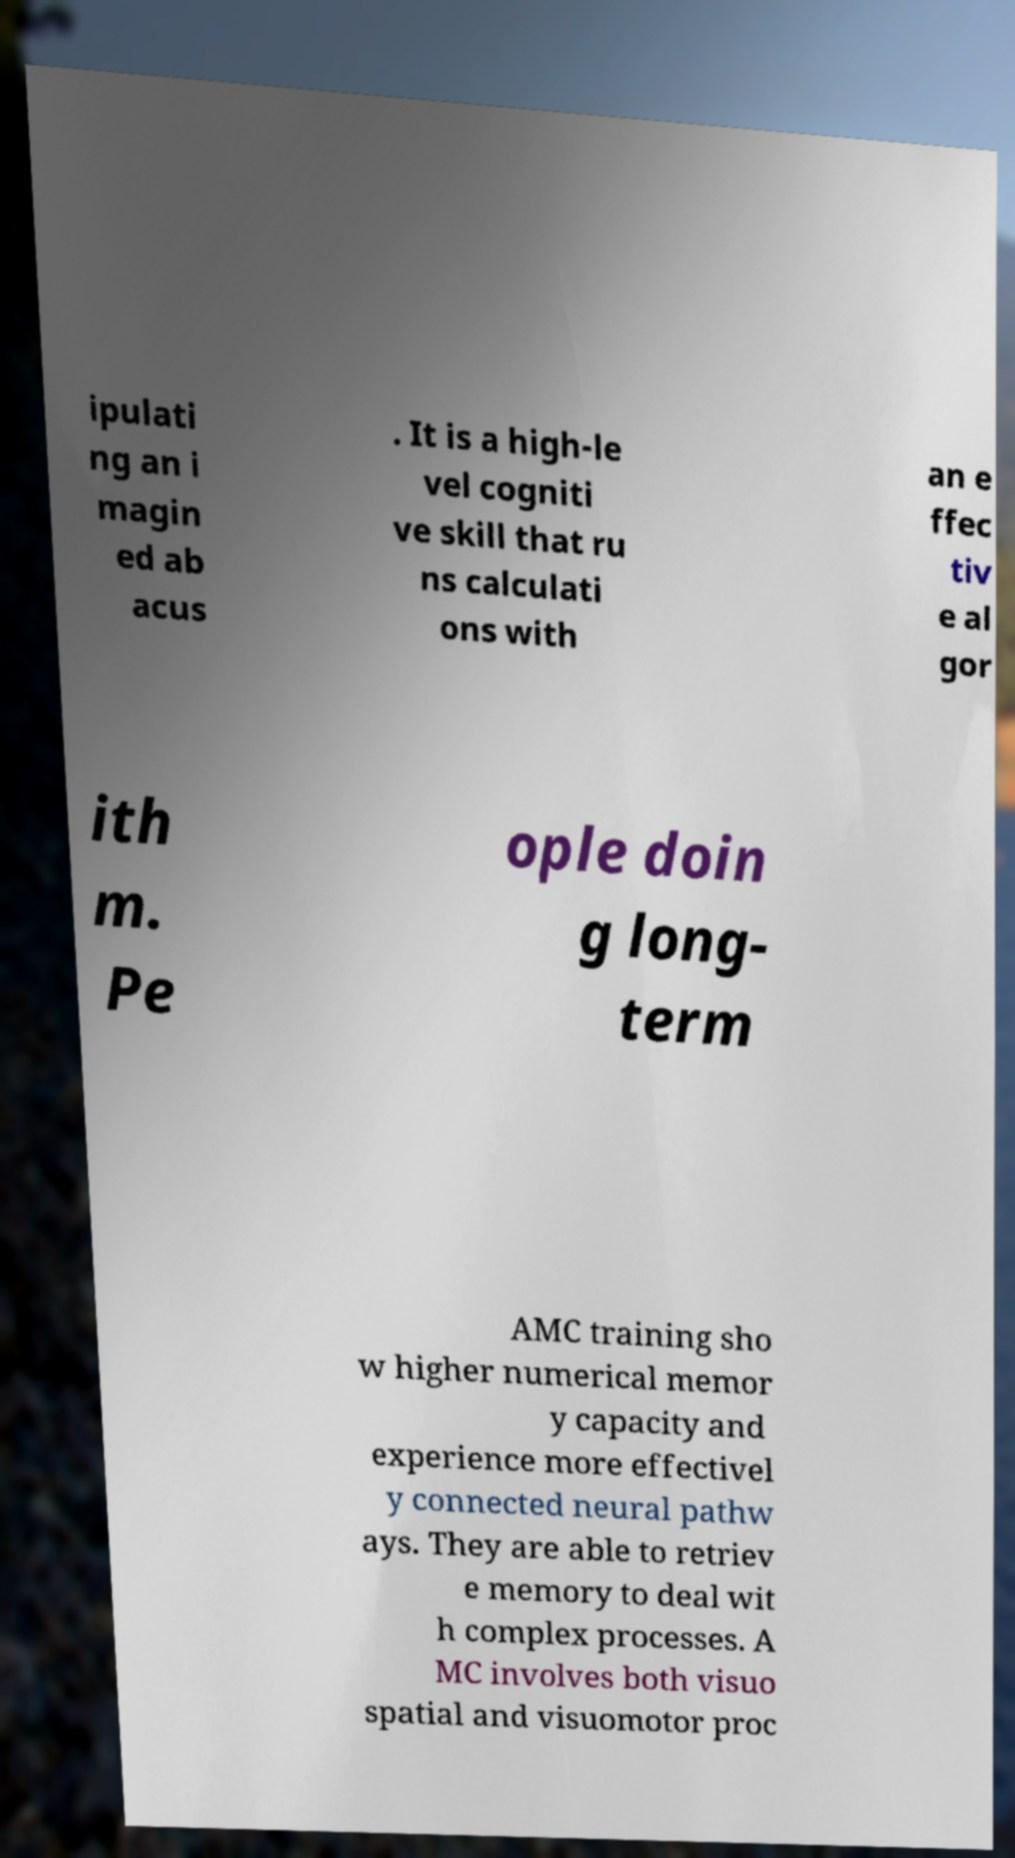Can you accurately transcribe the text from the provided image for me? ipulati ng an i magin ed ab acus . It is a high-le vel cogniti ve skill that ru ns calculati ons with an e ffec tiv e al gor ith m. Pe ople doin g long- term AMC training sho w higher numerical memor y capacity and experience more effectivel y connected neural pathw ays. They are able to retriev e memory to deal wit h complex processes. A MC involves both visuo spatial and visuomotor proc 